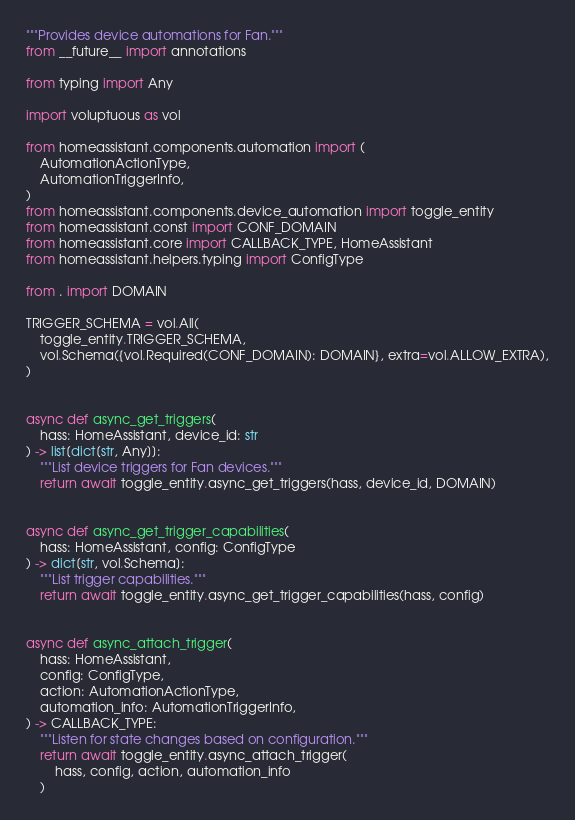<code> <loc_0><loc_0><loc_500><loc_500><_Python_>"""Provides device automations for Fan."""
from __future__ import annotations

from typing import Any

import voluptuous as vol

from homeassistant.components.automation import (
    AutomationActionType,
    AutomationTriggerInfo,
)
from homeassistant.components.device_automation import toggle_entity
from homeassistant.const import CONF_DOMAIN
from homeassistant.core import CALLBACK_TYPE, HomeAssistant
from homeassistant.helpers.typing import ConfigType

from . import DOMAIN

TRIGGER_SCHEMA = vol.All(
    toggle_entity.TRIGGER_SCHEMA,
    vol.Schema({vol.Required(CONF_DOMAIN): DOMAIN}, extra=vol.ALLOW_EXTRA),
)


async def async_get_triggers(
    hass: HomeAssistant, device_id: str
) -> list[dict[str, Any]]:
    """List device triggers for Fan devices."""
    return await toggle_entity.async_get_triggers(hass, device_id, DOMAIN)


async def async_get_trigger_capabilities(
    hass: HomeAssistant, config: ConfigType
) -> dict[str, vol.Schema]:
    """List trigger capabilities."""
    return await toggle_entity.async_get_trigger_capabilities(hass, config)


async def async_attach_trigger(
    hass: HomeAssistant,
    config: ConfigType,
    action: AutomationActionType,
    automation_info: AutomationTriggerInfo,
) -> CALLBACK_TYPE:
    """Listen for state changes based on configuration."""
    return await toggle_entity.async_attach_trigger(
        hass, config, action, automation_info
    )
</code> 